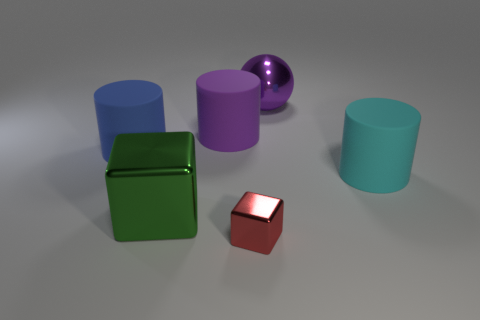Add 1 big shiny spheres. How many objects exist? 7 Subtract all blocks. How many objects are left? 4 Subtract all tiny red cubes. Subtract all cyan matte things. How many objects are left? 4 Add 5 red shiny cubes. How many red shiny cubes are left? 6 Add 2 large green blocks. How many large green blocks exist? 3 Subtract 0 green cylinders. How many objects are left? 6 